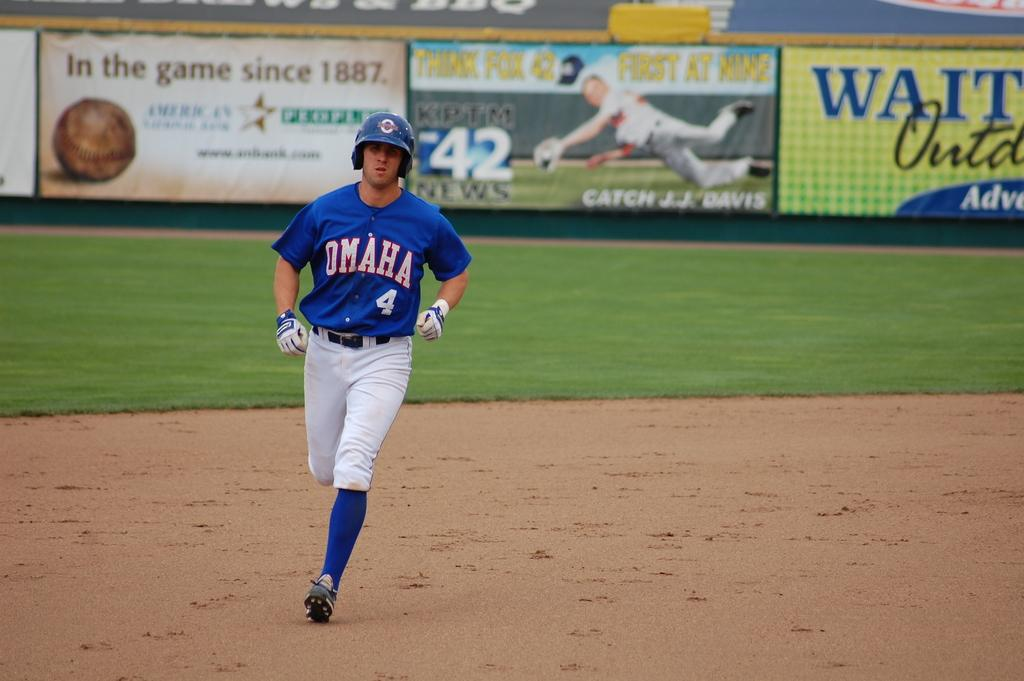<image>
Offer a succinct explanation of the picture presented. The player shown is wearing the number 4 on his top. 